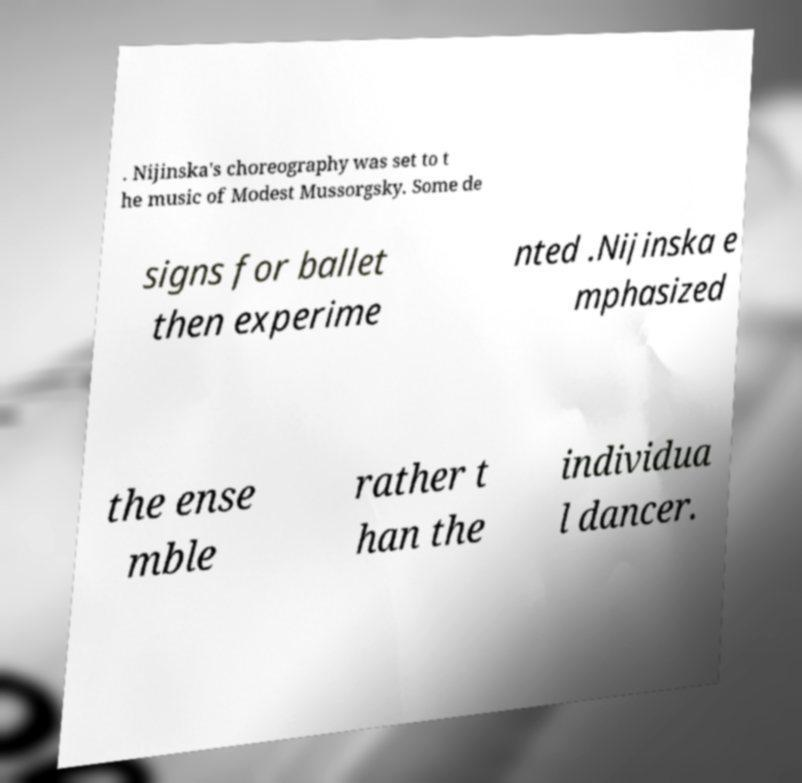Can you accurately transcribe the text from the provided image for me? . Nijinska's choreography was set to t he music of Modest Mussorgsky. Some de signs for ballet then experime nted .Nijinska e mphasized the ense mble rather t han the individua l dancer. 